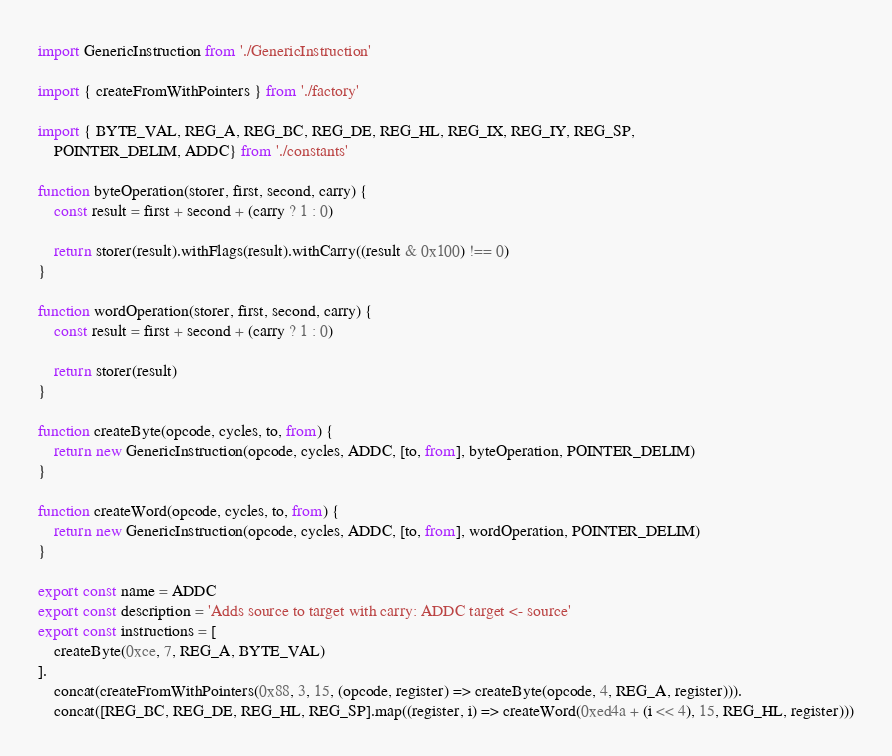<code> <loc_0><loc_0><loc_500><loc_500><_JavaScript_>import GenericInstruction from './GenericInstruction'

import { createFromWithPointers } from './factory'

import { BYTE_VAL, REG_A, REG_BC, REG_DE, REG_HL, REG_IX, REG_IY, REG_SP,
    POINTER_DELIM, ADDC} from './constants'

function byteOperation(storer, first, second, carry) {
    const result = first + second + (carry ? 1 : 0)

    return storer(result).withFlags(result).withCarry((result & 0x100) !== 0)
}

function wordOperation(storer, first, second, carry) {
    const result = first + second + (carry ? 1 : 0)

    return storer(result)
}

function createByte(opcode, cycles, to, from) {
    return new GenericInstruction(opcode, cycles, ADDC, [to, from], byteOperation, POINTER_DELIM)
}

function createWord(opcode, cycles, to, from) {
    return new GenericInstruction(opcode, cycles, ADDC, [to, from], wordOperation, POINTER_DELIM)
}

export const name = ADDC
export const description = 'Adds source to target with carry: ADDC target <- source'
export const instructions = [
    createByte(0xce, 7, REG_A, BYTE_VAL)
].
    concat(createFromWithPointers(0x88, 3, 15, (opcode, register) => createByte(opcode, 4, REG_A, register))).
    concat([REG_BC, REG_DE, REG_HL, REG_SP].map((register, i) => createWord(0xed4a + (i << 4), 15, REG_HL, register)))
</code> 